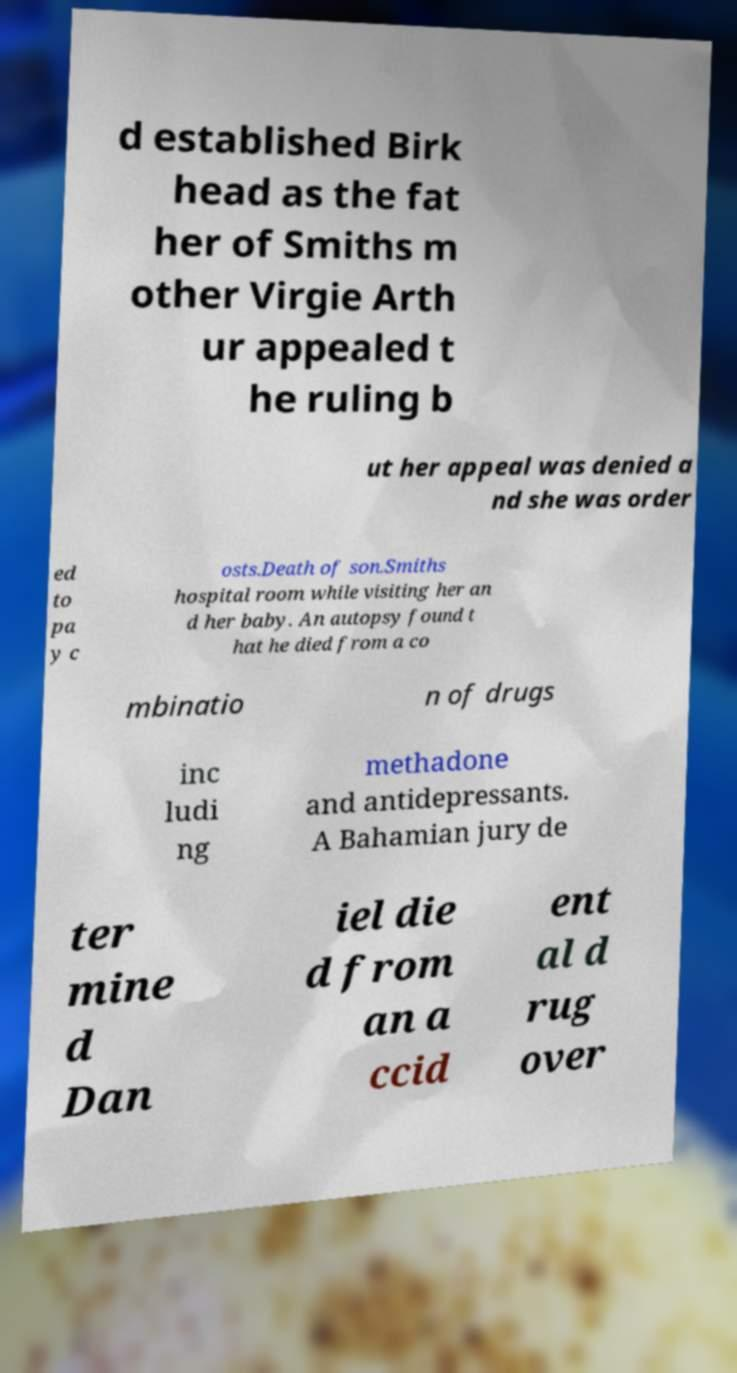Could you extract and type out the text from this image? d established Birk head as the fat her of Smiths m other Virgie Arth ur appealed t he ruling b ut her appeal was denied a nd she was order ed to pa y c osts.Death of son.Smiths hospital room while visiting her an d her baby. An autopsy found t hat he died from a co mbinatio n of drugs inc ludi ng methadone and antidepressants. A Bahamian jury de ter mine d Dan iel die d from an a ccid ent al d rug over 